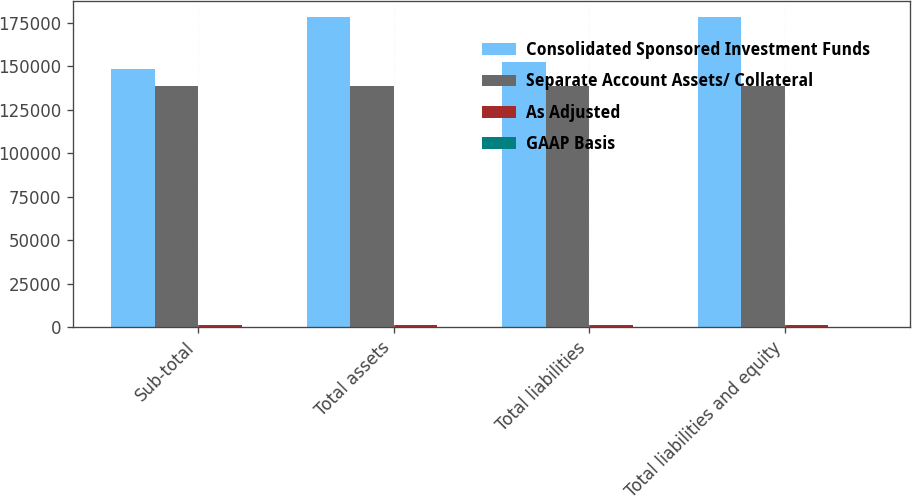Convert chart to OTSL. <chart><loc_0><loc_0><loc_500><loc_500><stacked_bar_chart><ecel><fcel>Sub-total<fcel>Total assets<fcel>Total liabilities<fcel>Total liabilities and equity<nl><fcel>Consolidated Sponsored Investment Funds<fcel>148142<fcel>178459<fcel>152125<fcel>178459<nl><fcel>Separate Account Assets/ Collateral<fcel>138775<fcel>138775<fcel>138775<fcel>138775<nl><fcel>As Adjusted<fcel>1405<fcel>1405<fcel>1285<fcel>1405<nl><fcel>GAAP Basis<fcel>205<fcel>205<fcel>10<fcel>205<nl></chart> 